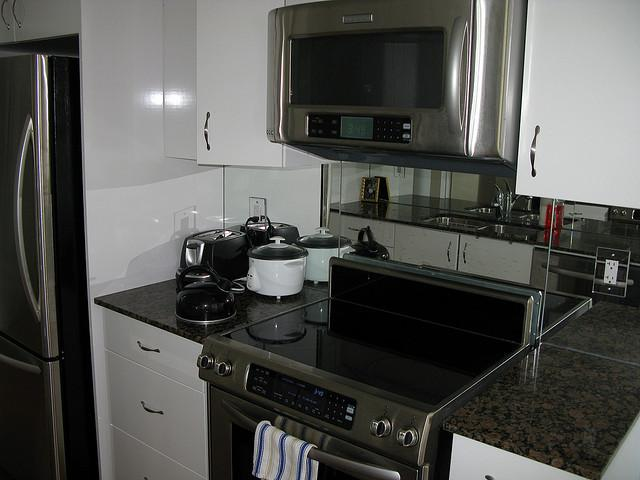What is the white cooker called? rice cooker 